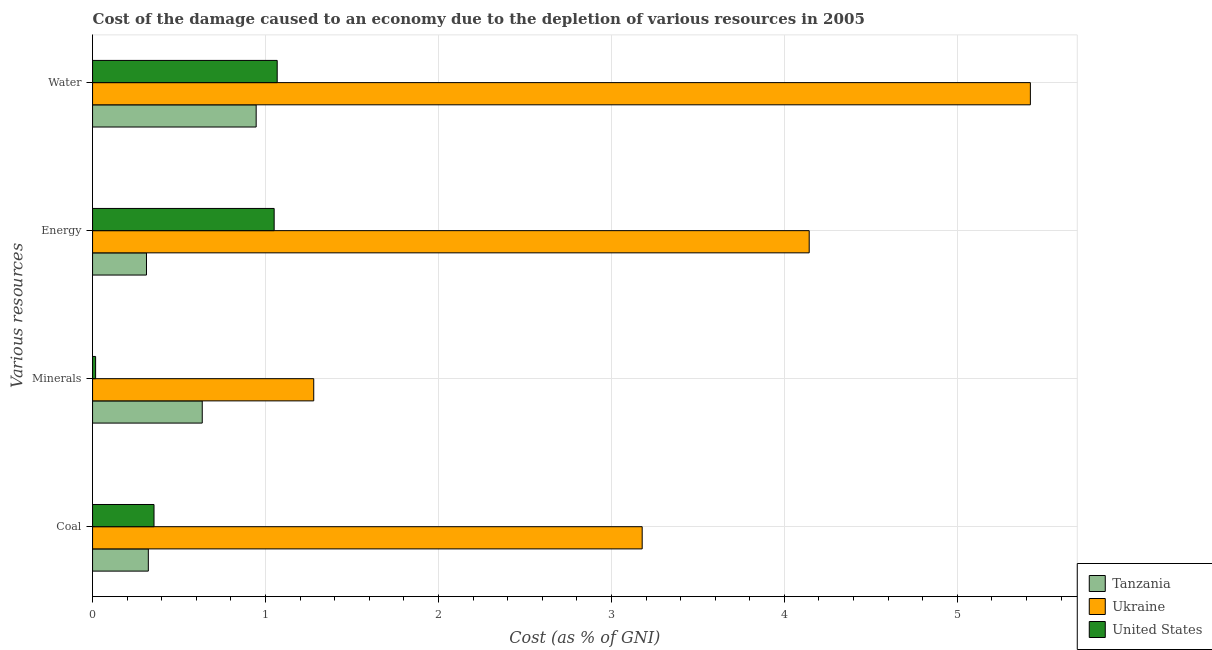How many different coloured bars are there?
Offer a terse response. 3. How many groups of bars are there?
Offer a very short reply. 4. How many bars are there on the 2nd tick from the top?
Your answer should be compact. 3. What is the label of the 3rd group of bars from the top?
Make the answer very short. Minerals. What is the cost of damage due to depletion of water in United States?
Offer a very short reply. 1.07. Across all countries, what is the maximum cost of damage due to depletion of minerals?
Provide a succinct answer. 1.28. Across all countries, what is the minimum cost of damage due to depletion of water?
Your response must be concise. 0.95. In which country was the cost of damage due to depletion of minerals maximum?
Offer a very short reply. Ukraine. In which country was the cost of damage due to depletion of coal minimum?
Ensure brevity in your answer.  Tanzania. What is the total cost of damage due to depletion of water in the graph?
Offer a very short reply. 7.44. What is the difference between the cost of damage due to depletion of coal in Tanzania and that in Ukraine?
Your response must be concise. -2.86. What is the difference between the cost of damage due to depletion of coal in Ukraine and the cost of damage due to depletion of minerals in United States?
Give a very brief answer. 3.16. What is the average cost of damage due to depletion of energy per country?
Keep it short and to the point. 1.84. What is the difference between the cost of damage due to depletion of energy and cost of damage due to depletion of water in Ukraine?
Provide a short and direct response. -1.28. In how many countries, is the cost of damage due to depletion of water greater than 0.2 %?
Keep it short and to the point. 3. What is the ratio of the cost of damage due to depletion of energy in Ukraine to that in Tanzania?
Provide a short and direct response. 13.29. Is the difference between the cost of damage due to depletion of minerals in Tanzania and Ukraine greater than the difference between the cost of damage due to depletion of energy in Tanzania and Ukraine?
Keep it short and to the point. Yes. What is the difference between the highest and the second highest cost of damage due to depletion of energy?
Keep it short and to the point. 3.09. What is the difference between the highest and the lowest cost of damage due to depletion of water?
Provide a succinct answer. 4.48. Is the sum of the cost of damage due to depletion of water in United States and Tanzania greater than the maximum cost of damage due to depletion of minerals across all countries?
Provide a short and direct response. Yes. What does the 3rd bar from the top in Energy represents?
Ensure brevity in your answer.  Tanzania. What does the 1st bar from the bottom in Minerals represents?
Your response must be concise. Tanzania. Is it the case that in every country, the sum of the cost of damage due to depletion of coal and cost of damage due to depletion of minerals is greater than the cost of damage due to depletion of energy?
Ensure brevity in your answer.  No. How many bars are there?
Offer a very short reply. 12. Are all the bars in the graph horizontal?
Provide a succinct answer. Yes. What is the title of the graph?
Make the answer very short. Cost of the damage caused to an economy due to the depletion of various resources in 2005 . Does "Sri Lanka" appear as one of the legend labels in the graph?
Your answer should be very brief. No. What is the label or title of the X-axis?
Offer a very short reply. Cost (as % of GNI). What is the label or title of the Y-axis?
Ensure brevity in your answer.  Various resources. What is the Cost (as % of GNI) in Tanzania in Coal?
Offer a very short reply. 0.32. What is the Cost (as % of GNI) in Ukraine in Coal?
Offer a terse response. 3.18. What is the Cost (as % of GNI) of United States in Coal?
Keep it short and to the point. 0.36. What is the Cost (as % of GNI) in Tanzania in Minerals?
Offer a very short reply. 0.63. What is the Cost (as % of GNI) in Ukraine in Minerals?
Provide a short and direct response. 1.28. What is the Cost (as % of GNI) of United States in Minerals?
Give a very brief answer. 0.02. What is the Cost (as % of GNI) of Tanzania in Energy?
Ensure brevity in your answer.  0.31. What is the Cost (as % of GNI) of Ukraine in Energy?
Provide a succinct answer. 4.14. What is the Cost (as % of GNI) in United States in Energy?
Your response must be concise. 1.05. What is the Cost (as % of GNI) in Tanzania in Water?
Offer a terse response. 0.95. What is the Cost (as % of GNI) in Ukraine in Water?
Provide a succinct answer. 5.42. What is the Cost (as % of GNI) in United States in Water?
Provide a succinct answer. 1.07. Across all Various resources, what is the maximum Cost (as % of GNI) in Tanzania?
Keep it short and to the point. 0.95. Across all Various resources, what is the maximum Cost (as % of GNI) in Ukraine?
Your answer should be compact. 5.42. Across all Various resources, what is the maximum Cost (as % of GNI) in United States?
Your response must be concise. 1.07. Across all Various resources, what is the minimum Cost (as % of GNI) of Tanzania?
Provide a short and direct response. 0.31. Across all Various resources, what is the minimum Cost (as % of GNI) of Ukraine?
Provide a short and direct response. 1.28. Across all Various resources, what is the minimum Cost (as % of GNI) of United States?
Ensure brevity in your answer.  0.02. What is the total Cost (as % of GNI) in Tanzania in the graph?
Keep it short and to the point. 2.21. What is the total Cost (as % of GNI) in Ukraine in the graph?
Make the answer very short. 14.02. What is the total Cost (as % of GNI) in United States in the graph?
Ensure brevity in your answer.  2.49. What is the difference between the Cost (as % of GNI) of Tanzania in Coal and that in Minerals?
Your response must be concise. -0.31. What is the difference between the Cost (as % of GNI) of Ukraine in Coal and that in Minerals?
Offer a very short reply. 1.9. What is the difference between the Cost (as % of GNI) of United States in Coal and that in Minerals?
Make the answer very short. 0.34. What is the difference between the Cost (as % of GNI) of Tanzania in Coal and that in Energy?
Your answer should be compact. 0.01. What is the difference between the Cost (as % of GNI) in Ukraine in Coal and that in Energy?
Keep it short and to the point. -0.97. What is the difference between the Cost (as % of GNI) of United States in Coal and that in Energy?
Provide a succinct answer. -0.69. What is the difference between the Cost (as % of GNI) in Tanzania in Coal and that in Water?
Provide a succinct answer. -0.62. What is the difference between the Cost (as % of GNI) of Ukraine in Coal and that in Water?
Offer a very short reply. -2.24. What is the difference between the Cost (as % of GNI) of United States in Coal and that in Water?
Give a very brief answer. -0.71. What is the difference between the Cost (as % of GNI) of Tanzania in Minerals and that in Energy?
Provide a short and direct response. 0.32. What is the difference between the Cost (as % of GNI) in Ukraine in Minerals and that in Energy?
Ensure brevity in your answer.  -2.86. What is the difference between the Cost (as % of GNI) of United States in Minerals and that in Energy?
Ensure brevity in your answer.  -1.03. What is the difference between the Cost (as % of GNI) of Tanzania in Minerals and that in Water?
Provide a short and direct response. -0.31. What is the difference between the Cost (as % of GNI) in Ukraine in Minerals and that in Water?
Your response must be concise. -4.14. What is the difference between the Cost (as % of GNI) in United States in Minerals and that in Water?
Offer a terse response. -1.05. What is the difference between the Cost (as % of GNI) in Tanzania in Energy and that in Water?
Give a very brief answer. -0.63. What is the difference between the Cost (as % of GNI) of Ukraine in Energy and that in Water?
Provide a succinct answer. -1.28. What is the difference between the Cost (as % of GNI) in United States in Energy and that in Water?
Your answer should be very brief. -0.02. What is the difference between the Cost (as % of GNI) of Tanzania in Coal and the Cost (as % of GNI) of Ukraine in Minerals?
Provide a succinct answer. -0.96. What is the difference between the Cost (as % of GNI) of Tanzania in Coal and the Cost (as % of GNI) of United States in Minerals?
Give a very brief answer. 0.3. What is the difference between the Cost (as % of GNI) of Ukraine in Coal and the Cost (as % of GNI) of United States in Minerals?
Give a very brief answer. 3.16. What is the difference between the Cost (as % of GNI) of Tanzania in Coal and the Cost (as % of GNI) of Ukraine in Energy?
Keep it short and to the point. -3.82. What is the difference between the Cost (as % of GNI) in Tanzania in Coal and the Cost (as % of GNI) in United States in Energy?
Your answer should be very brief. -0.73. What is the difference between the Cost (as % of GNI) in Ukraine in Coal and the Cost (as % of GNI) in United States in Energy?
Provide a succinct answer. 2.13. What is the difference between the Cost (as % of GNI) of Tanzania in Coal and the Cost (as % of GNI) of Ukraine in Water?
Offer a very short reply. -5.1. What is the difference between the Cost (as % of GNI) of Tanzania in Coal and the Cost (as % of GNI) of United States in Water?
Make the answer very short. -0.75. What is the difference between the Cost (as % of GNI) of Ukraine in Coal and the Cost (as % of GNI) of United States in Water?
Give a very brief answer. 2.11. What is the difference between the Cost (as % of GNI) of Tanzania in Minerals and the Cost (as % of GNI) of Ukraine in Energy?
Offer a terse response. -3.51. What is the difference between the Cost (as % of GNI) of Tanzania in Minerals and the Cost (as % of GNI) of United States in Energy?
Ensure brevity in your answer.  -0.42. What is the difference between the Cost (as % of GNI) in Ukraine in Minerals and the Cost (as % of GNI) in United States in Energy?
Your response must be concise. 0.23. What is the difference between the Cost (as % of GNI) in Tanzania in Minerals and the Cost (as % of GNI) in Ukraine in Water?
Your answer should be compact. -4.79. What is the difference between the Cost (as % of GNI) in Tanzania in Minerals and the Cost (as % of GNI) in United States in Water?
Ensure brevity in your answer.  -0.43. What is the difference between the Cost (as % of GNI) in Ukraine in Minerals and the Cost (as % of GNI) in United States in Water?
Provide a short and direct response. 0.21. What is the difference between the Cost (as % of GNI) in Tanzania in Energy and the Cost (as % of GNI) in Ukraine in Water?
Your response must be concise. -5.11. What is the difference between the Cost (as % of GNI) in Tanzania in Energy and the Cost (as % of GNI) in United States in Water?
Provide a short and direct response. -0.76. What is the difference between the Cost (as % of GNI) in Ukraine in Energy and the Cost (as % of GNI) in United States in Water?
Give a very brief answer. 3.08. What is the average Cost (as % of GNI) of Tanzania per Various resources?
Ensure brevity in your answer.  0.55. What is the average Cost (as % of GNI) in Ukraine per Various resources?
Your answer should be compact. 3.51. What is the average Cost (as % of GNI) in United States per Various resources?
Your answer should be very brief. 0.62. What is the difference between the Cost (as % of GNI) of Tanzania and Cost (as % of GNI) of Ukraine in Coal?
Your answer should be compact. -2.86. What is the difference between the Cost (as % of GNI) in Tanzania and Cost (as % of GNI) in United States in Coal?
Your response must be concise. -0.03. What is the difference between the Cost (as % of GNI) in Ukraine and Cost (as % of GNI) in United States in Coal?
Give a very brief answer. 2.82. What is the difference between the Cost (as % of GNI) of Tanzania and Cost (as % of GNI) of Ukraine in Minerals?
Offer a very short reply. -0.64. What is the difference between the Cost (as % of GNI) of Tanzania and Cost (as % of GNI) of United States in Minerals?
Your answer should be very brief. 0.62. What is the difference between the Cost (as % of GNI) of Ukraine and Cost (as % of GNI) of United States in Minerals?
Your response must be concise. 1.26. What is the difference between the Cost (as % of GNI) of Tanzania and Cost (as % of GNI) of Ukraine in Energy?
Your answer should be compact. -3.83. What is the difference between the Cost (as % of GNI) in Tanzania and Cost (as % of GNI) in United States in Energy?
Make the answer very short. -0.74. What is the difference between the Cost (as % of GNI) in Ukraine and Cost (as % of GNI) in United States in Energy?
Your answer should be very brief. 3.09. What is the difference between the Cost (as % of GNI) of Tanzania and Cost (as % of GNI) of Ukraine in Water?
Provide a succinct answer. -4.48. What is the difference between the Cost (as % of GNI) of Tanzania and Cost (as % of GNI) of United States in Water?
Provide a short and direct response. -0.12. What is the difference between the Cost (as % of GNI) in Ukraine and Cost (as % of GNI) in United States in Water?
Give a very brief answer. 4.35. What is the ratio of the Cost (as % of GNI) in Tanzania in Coal to that in Minerals?
Keep it short and to the point. 0.51. What is the ratio of the Cost (as % of GNI) in Ukraine in Coal to that in Minerals?
Keep it short and to the point. 2.49. What is the ratio of the Cost (as % of GNI) of United States in Coal to that in Minerals?
Ensure brevity in your answer.  20.24. What is the ratio of the Cost (as % of GNI) in Tanzania in Coal to that in Energy?
Your answer should be compact. 1.03. What is the ratio of the Cost (as % of GNI) in Ukraine in Coal to that in Energy?
Provide a short and direct response. 0.77. What is the ratio of the Cost (as % of GNI) in United States in Coal to that in Energy?
Offer a terse response. 0.34. What is the ratio of the Cost (as % of GNI) in Tanzania in Coal to that in Water?
Keep it short and to the point. 0.34. What is the ratio of the Cost (as % of GNI) of Ukraine in Coal to that in Water?
Keep it short and to the point. 0.59. What is the ratio of the Cost (as % of GNI) of United States in Coal to that in Water?
Your response must be concise. 0.33. What is the ratio of the Cost (as % of GNI) in Tanzania in Minerals to that in Energy?
Offer a very short reply. 2.03. What is the ratio of the Cost (as % of GNI) of Ukraine in Minerals to that in Energy?
Ensure brevity in your answer.  0.31. What is the ratio of the Cost (as % of GNI) of United States in Minerals to that in Energy?
Offer a very short reply. 0.02. What is the ratio of the Cost (as % of GNI) in Tanzania in Minerals to that in Water?
Offer a terse response. 0.67. What is the ratio of the Cost (as % of GNI) of Ukraine in Minerals to that in Water?
Your answer should be very brief. 0.24. What is the ratio of the Cost (as % of GNI) of United States in Minerals to that in Water?
Provide a succinct answer. 0.02. What is the ratio of the Cost (as % of GNI) of Tanzania in Energy to that in Water?
Your answer should be very brief. 0.33. What is the ratio of the Cost (as % of GNI) in Ukraine in Energy to that in Water?
Provide a succinct answer. 0.76. What is the ratio of the Cost (as % of GNI) of United States in Energy to that in Water?
Your answer should be very brief. 0.98. What is the difference between the highest and the second highest Cost (as % of GNI) of Tanzania?
Your response must be concise. 0.31. What is the difference between the highest and the second highest Cost (as % of GNI) in Ukraine?
Your answer should be compact. 1.28. What is the difference between the highest and the second highest Cost (as % of GNI) in United States?
Give a very brief answer. 0.02. What is the difference between the highest and the lowest Cost (as % of GNI) of Tanzania?
Give a very brief answer. 0.63. What is the difference between the highest and the lowest Cost (as % of GNI) of Ukraine?
Ensure brevity in your answer.  4.14. What is the difference between the highest and the lowest Cost (as % of GNI) in United States?
Give a very brief answer. 1.05. 